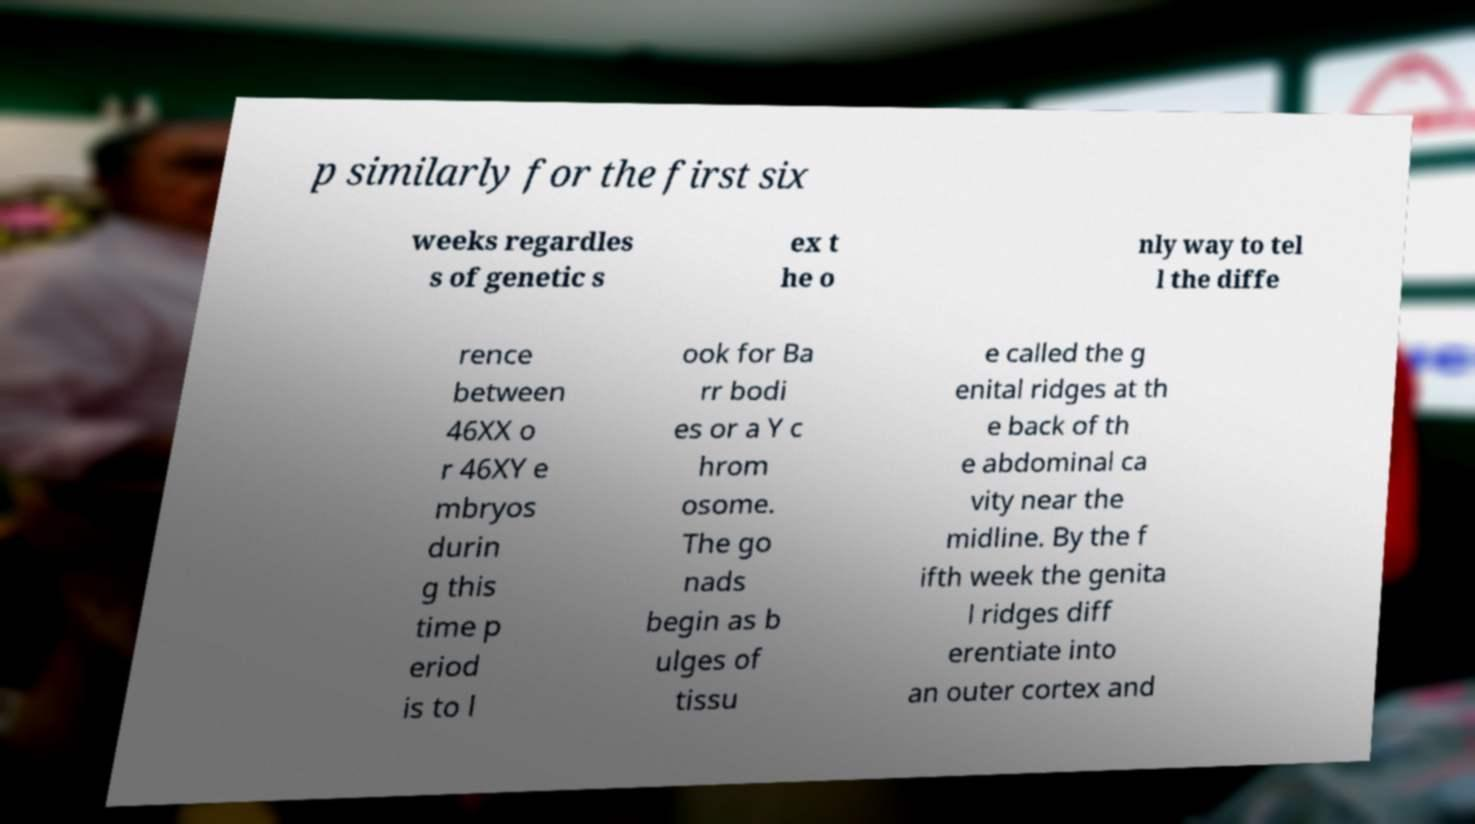I need the written content from this picture converted into text. Can you do that? p similarly for the first six weeks regardles s of genetic s ex t he o nly way to tel l the diffe rence between 46XX o r 46XY e mbryos durin g this time p eriod is to l ook for Ba rr bodi es or a Y c hrom osome. The go nads begin as b ulges of tissu e called the g enital ridges at th e back of th e abdominal ca vity near the midline. By the f ifth week the genita l ridges diff erentiate into an outer cortex and 